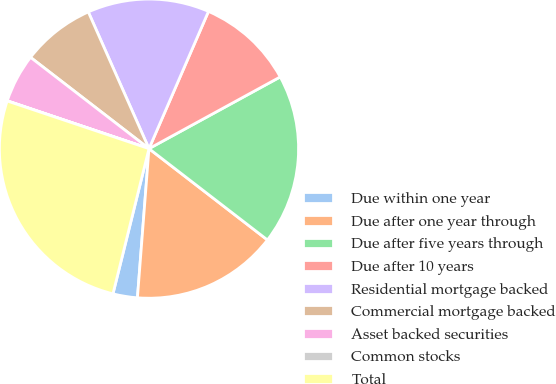<chart> <loc_0><loc_0><loc_500><loc_500><pie_chart><fcel>Due within one year<fcel>Due after one year through<fcel>Due after five years through<fcel>Due after 10 years<fcel>Residential mortgage backed<fcel>Commercial mortgage backed<fcel>Asset backed securities<fcel>Common stocks<fcel>Total<nl><fcel>2.64%<fcel>15.78%<fcel>18.41%<fcel>10.53%<fcel>13.16%<fcel>7.9%<fcel>5.27%<fcel>0.02%<fcel>26.29%<nl></chart> 